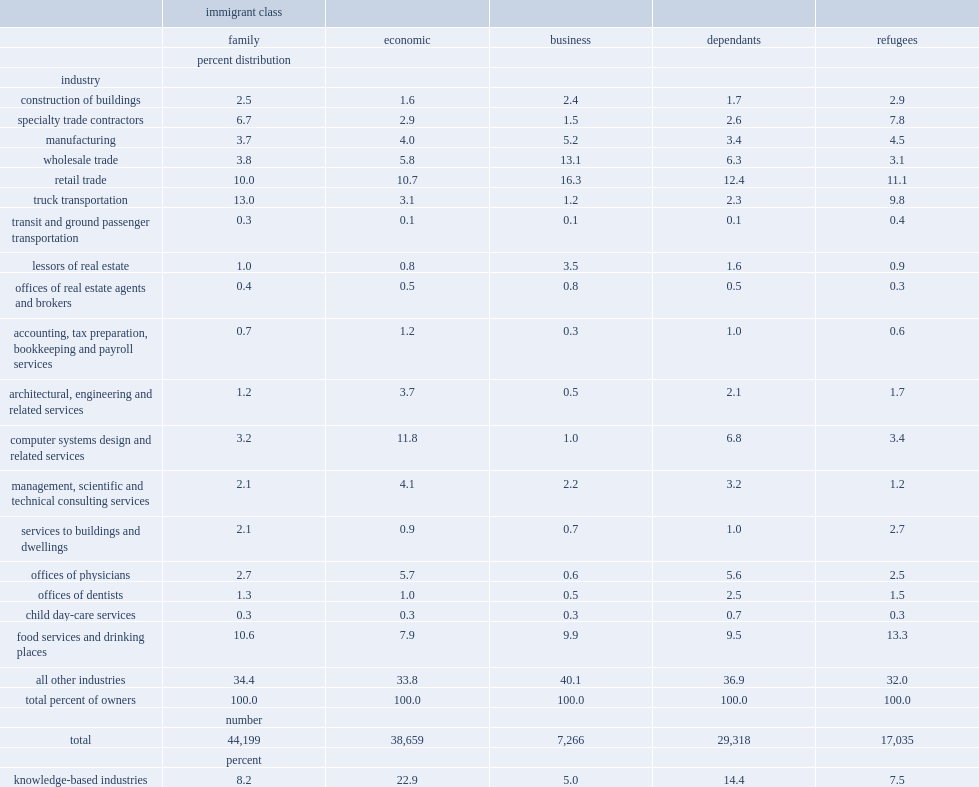How many percent of private incorporated companies owned by the economic class pas were in kowledge-based industries? 22.9. What proportion of private incorporated companies owned by the economic class pas were in retail trade or food services. 18.6. How many percent of the incorporated businesses owned by dependants of economic pas were in retail trade or food services? 21.9. How many percent of the incorporated businesses owned by dependants of economic pas were in knowledge-based industries? 14.4. List top three self-employment among economic class dependants. Retail trade services to buildings and dwellings lessors of real estate. 